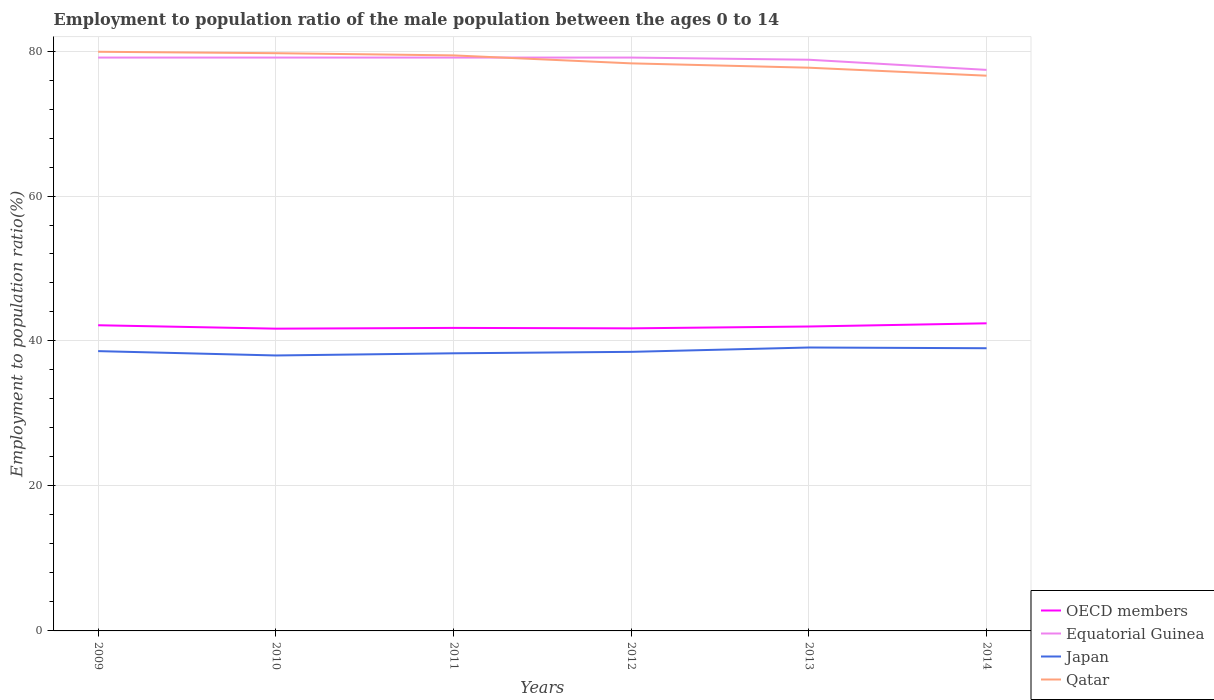Does the line corresponding to Japan intersect with the line corresponding to Equatorial Guinea?
Ensure brevity in your answer.  No. Across all years, what is the maximum employment to population ratio in OECD members?
Offer a very short reply. 41.7. In which year was the employment to population ratio in Equatorial Guinea maximum?
Your answer should be very brief. 2014. What is the total employment to population ratio in Equatorial Guinea in the graph?
Your response must be concise. 1.7. What is the difference between the highest and the second highest employment to population ratio in OECD members?
Provide a short and direct response. 0.74. Is the employment to population ratio in OECD members strictly greater than the employment to population ratio in Japan over the years?
Your answer should be very brief. No. How many lines are there?
Your response must be concise. 4. Are the values on the major ticks of Y-axis written in scientific E-notation?
Make the answer very short. No. Does the graph contain any zero values?
Your response must be concise. No. How are the legend labels stacked?
Your response must be concise. Vertical. What is the title of the graph?
Ensure brevity in your answer.  Employment to population ratio of the male population between the ages 0 to 14. Does "Turkey" appear as one of the legend labels in the graph?
Keep it short and to the point. No. What is the label or title of the X-axis?
Give a very brief answer. Years. What is the label or title of the Y-axis?
Provide a short and direct response. Employment to population ratio(%). What is the Employment to population ratio(%) in OECD members in 2009?
Offer a terse response. 42.17. What is the Employment to population ratio(%) in Equatorial Guinea in 2009?
Give a very brief answer. 79.1. What is the Employment to population ratio(%) of Japan in 2009?
Your answer should be very brief. 38.6. What is the Employment to population ratio(%) in Qatar in 2009?
Your answer should be compact. 79.9. What is the Employment to population ratio(%) of OECD members in 2010?
Give a very brief answer. 41.7. What is the Employment to population ratio(%) of Equatorial Guinea in 2010?
Your response must be concise. 79.1. What is the Employment to population ratio(%) in Japan in 2010?
Ensure brevity in your answer.  38. What is the Employment to population ratio(%) in Qatar in 2010?
Your response must be concise. 79.7. What is the Employment to population ratio(%) in OECD members in 2011?
Make the answer very short. 41.8. What is the Employment to population ratio(%) in Equatorial Guinea in 2011?
Your answer should be very brief. 79.1. What is the Employment to population ratio(%) of Japan in 2011?
Your answer should be very brief. 38.3. What is the Employment to population ratio(%) of Qatar in 2011?
Your answer should be compact. 79.4. What is the Employment to population ratio(%) of OECD members in 2012?
Keep it short and to the point. 41.74. What is the Employment to population ratio(%) of Equatorial Guinea in 2012?
Ensure brevity in your answer.  79.1. What is the Employment to population ratio(%) in Japan in 2012?
Keep it short and to the point. 38.5. What is the Employment to population ratio(%) in Qatar in 2012?
Make the answer very short. 78.3. What is the Employment to population ratio(%) in OECD members in 2013?
Your answer should be compact. 42. What is the Employment to population ratio(%) of Equatorial Guinea in 2013?
Provide a short and direct response. 78.8. What is the Employment to population ratio(%) of Japan in 2013?
Provide a short and direct response. 39.1. What is the Employment to population ratio(%) of Qatar in 2013?
Give a very brief answer. 77.7. What is the Employment to population ratio(%) in OECD members in 2014?
Give a very brief answer. 42.44. What is the Employment to population ratio(%) of Equatorial Guinea in 2014?
Offer a terse response. 77.4. What is the Employment to population ratio(%) in Japan in 2014?
Offer a terse response. 39. What is the Employment to population ratio(%) of Qatar in 2014?
Provide a succinct answer. 76.6. Across all years, what is the maximum Employment to population ratio(%) in OECD members?
Your response must be concise. 42.44. Across all years, what is the maximum Employment to population ratio(%) of Equatorial Guinea?
Provide a short and direct response. 79.1. Across all years, what is the maximum Employment to population ratio(%) in Japan?
Your response must be concise. 39.1. Across all years, what is the maximum Employment to population ratio(%) in Qatar?
Provide a succinct answer. 79.9. Across all years, what is the minimum Employment to population ratio(%) in OECD members?
Make the answer very short. 41.7. Across all years, what is the minimum Employment to population ratio(%) in Equatorial Guinea?
Provide a short and direct response. 77.4. Across all years, what is the minimum Employment to population ratio(%) of Japan?
Keep it short and to the point. 38. Across all years, what is the minimum Employment to population ratio(%) of Qatar?
Make the answer very short. 76.6. What is the total Employment to population ratio(%) in OECD members in the graph?
Offer a terse response. 251.85. What is the total Employment to population ratio(%) of Equatorial Guinea in the graph?
Your answer should be compact. 472.6. What is the total Employment to population ratio(%) in Japan in the graph?
Offer a very short reply. 231.5. What is the total Employment to population ratio(%) in Qatar in the graph?
Keep it short and to the point. 471.6. What is the difference between the Employment to population ratio(%) of OECD members in 2009 and that in 2010?
Provide a short and direct response. 0.47. What is the difference between the Employment to population ratio(%) in Japan in 2009 and that in 2010?
Provide a short and direct response. 0.6. What is the difference between the Employment to population ratio(%) in Qatar in 2009 and that in 2010?
Your answer should be very brief. 0.2. What is the difference between the Employment to population ratio(%) in OECD members in 2009 and that in 2011?
Ensure brevity in your answer.  0.37. What is the difference between the Employment to population ratio(%) in Equatorial Guinea in 2009 and that in 2011?
Give a very brief answer. 0. What is the difference between the Employment to population ratio(%) of Japan in 2009 and that in 2011?
Your answer should be compact. 0.3. What is the difference between the Employment to population ratio(%) in Qatar in 2009 and that in 2011?
Give a very brief answer. 0.5. What is the difference between the Employment to population ratio(%) in OECD members in 2009 and that in 2012?
Your answer should be very brief. 0.43. What is the difference between the Employment to population ratio(%) in Equatorial Guinea in 2009 and that in 2012?
Make the answer very short. 0. What is the difference between the Employment to population ratio(%) of OECD members in 2009 and that in 2013?
Provide a succinct answer. 0.17. What is the difference between the Employment to population ratio(%) of Equatorial Guinea in 2009 and that in 2013?
Ensure brevity in your answer.  0.3. What is the difference between the Employment to population ratio(%) of OECD members in 2009 and that in 2014?
Ensure brevity in your answer.  -0.27. What is the difference between the Employment to population ratio(%) in Equatorial Guinea in 2009 and that in 2014?
Your response must be concise. 1.7. What is the difference between the Employment to population ratio(%) of Japan in 2009 and that in 2014?
Ensure brevity in your answer.  -0.4. What is the difference between the Employment to population ratio(%) of OECD members in 2010 and that in 2011?
Your response must be concise. -0.1. What is the difference between the Employment to population ratio(%) of Japan in 2010 and that in 2011?
Keep it short and to the point. -0.3. What is the difference between the Employment to population ratio(%) in Qatar in 2010 and that in 2011?
Provide a succinct answer. 0.3. What is the difference between the Employment to population ratio(%) in OECD members in 2010 and that in 2012?
Your answer should be very brief. -0.04. What is the difference between the Employment to population ratio(%) in Equatorial Guinea in 2010 and that in 2012?
Offer a terse response. 0. What is the difference between the Employment to population ratio(%) of OECD members in 2010 and that in 2013?
Your answer should be very brief. -0.3. What is the difference between the Employment to population ratio(%) of Equatorial Guinea in 2010 and that in 2013?
Your answer should be compact. 0.3. What is the difference between the Employment to population ratio(%) of Qatar in 2010 and that in 2013?
Ensure brevity in your answer.  2. What is the difference between the Employment to population ratio(%) of OECD members in 2010 and that in 2014?
Your response must be concise. -0.74. What is the difference between the Employment to population ratio(%) in Qatar in 2010 and that in 2014?
Give a very brief answer. 3.1. What is the difference between the Employment to population ratio(%) of OECD members in 2011 and that in 2012?
Ensure brevity in your answer.  0.06. What is the difference between the Employment to population ratio(%) of Equatorial Guinea in 2011 and that in 2012?
Keep it short and to the point. 0. What is the difference between the Employment to population ratio(%) of Japan in 2011 and that in 2012?
Offer a terse response. -0.2. What is the difference between the Employment to population ratio(%) in Qatar in 2011 and that in 2012?
Give a very brief answer. 1.1. What is the difference between the Employment to population ratio(%) in OECD members in 2011 and that in 2013?
Your answer should be compact. -0.19. What is the difference between the Employment to population ratio(%) in Equatorial Guinea in 2011 and that in 2013?
Offer a very short reply. 0.3. What is the difference between the Employment to population ratio(%) in Japan in 2011 and that in 2013?
Ensure brevity in your answer.  -0.8. What is the difference between the Employment to population ratio(%) of Qatar in 2011 and that in 2013?
Provide a succinct answer. 1.7. What is the difference between the Employment to population ratio(%) in OECD members in 2011 and that in 2014?
Your response must be concise. -0.63. What is the difference between the Employment to population ratio(%) of Equatorial Guinea in 2011 and that in 2014?
Give a very brief answer. 1.7. What is the difference between the Employment to population ratio(%) in Japan in 2011 and that in 2014?
Provide a short and direct response. -0.7. What is the difference between the Employment to population ratio(%) in OECD members in 2012 and that in 2013?
Keep it short and to the point. -0.25. What is the difference between the Employment to population ratio(%) of Equatorial Guinea in 2012 and that in 2013?
Offer a terse response. 0.3. What is the difference between the Employment to population ratio(%) of Qatar in 2012 and that in 2013?
Give a very brief answer. 0.6. What is the difference between the Employment to population ratio(%) of OECD members in 2012 and that in 2014?
Make the answer very short. -0.69. What is the difference between the Employment to population ratio(%) in Equatorial Guinea in 2012 and that in 2014?
Your response must be concise. 1.7. What is the difference between the Employment to population ratio(%) in Qatar in 2012 and that in 2014?
Your answer should be very brief. 1.7. What is the difference between the Employment to population ratio(%) of OECD members in 2013 and that in 2014?
Your answer should be very brief. -0.44. What is the difference between the Employment to population ratio(%) in OECD members in 2009 and the Employment to population ratio(%) in Equatorial Guinea in 2010?
Offer a terse response. -36.93. What is the difference between the Employment to population ratio(%) in OECD members in 2009 and the Employment to population ratio(%) in Japan in 2010?
Make the answer very short. 4.17. What is the difference between the Employment to population ratio(%) of OECD members in 2009 and the Employment to population ratio(%) of Qatar in 2010?
Offer a terse response. -37.53. What is the difference between the Employment to population ratio(%) of Equatorial Guinea in 2009 and the Employment to population ratio(%) of Japan in 2010?
Your response must be concise. 41.1. What is the difference between the Employment to population ratio(%) in Equatorial Guinea in 2009 and the Employment to population ratio(%) in Qatar in 2010?
Ensure brevity in your answer.  -0.6. What is the difference between the Employment to population ratio(%) in Japan in 2009 and the Employment to population ratio(%) in Qatar in 2010?
Offer a terse response. -41.1. What is the difference between the Employment to population ratio(%) of OECD members in 2009 and the Employment to population ratio(%) of Equatorial Guinea in 2011?
Offer a very short reply. -36.93. What is the difference between the Employment to population ratio(%) in OECD members in 2009 and the Employment to population ratio(%) in Japan in 2011?
Your answer should be compact. 3.87. What is the difference between the Employment to population ratio(%) of OECD members in 2009 and the Employment to population ratio(%) of Qatar in 2011?
Keep it short and to the point. -37.23. What is the difference between the Employment to population ratio(%) in Equatorial Guinea in 2009 and the Employment to population ratio(%) in Japan in 2011?
Keep it short and to the point. 40.8. What is the difference between the Employment to population ratio(%) in Japan in 2009 and the Employment to population ratio(%) in Qatar in 2011?
Keep it short and to the point. -40.8. What is the difference between the Employment to population ratio(%) in OECD members in 2009 and the Employment to population ratio(%) in Equatorial Guinea in 2012?
Offer a terse response. -36.93. What is the difference between the Employment to population ratio(%) in OECD members in 2009 and the Employment to population ratio(%) in Japan in 2012?
Keep it short and to the point. 3.67. What is the difference between the Employment to population ratio(%) of OECD members in 2009 and the Employment to population ratio(%) of Qatar in 2012?
Your answer should be compact. -36.13. What is the difference between the Employment to population ratio(%) in Equatorial Guinea in 2009 and the Employment to population ratio(%) in Japan in 2012?
Offer a terse response. 40.6. What is the difference between the Employment to population ratio(%) in Japan in 2009 and the Employment to population ratio(%) in Qatar in 2012?
Offer a very short reply. -39.7. What is the difference between the Employment to population ratio(%) in OECD members in 2009 and the Employment to population ratio(%) in Equatorial Guinea in 2013?
Your response must be concise. -36.63. What is the difference between the Employment to population ratio(%) of OECD members in 2009 and the Employment to population ratio(%) of Japan in 2013?
Ensure brevity in your answer.  3.07. What is the difference between the Employment to population ratio(%) of OECD members in 2009 and the Employment to population ratio(%) of Qatar in 2013?
Keep it short and to the point. -35.53. What is the difference between the Employment to population ratio(%) of Equatorial Guinea in 2009 and the Employment to population ratio(%) of Qatar in 2013?
Keep it short and to the point. 1.4. What is the difference between the Employment to population ratio(%) in Japan in 2009 and the Employment to population ratio(%) in Qatar in 2013?
Offer a terse response. -39.1. What is the difference between the Employment to population ratio(%) in OECD members in 2009 and the Employment to population ratio(%) in Equatorial Guinea in 2014?
Your answer should be very brief. -35.23. What is the difference between the Employment to population ratio(%) of OECD members in 2009 and the Employment to population ratio(%) of Japan in 2014?
Offer a very short reply. 3.17. What is the difference between the Employment to population ratio(%) of OECD members in 2009 and the Employment to population ratio(%) of Qatar in 2014?
Provide a short and direct response. -34.43. What is the difference between the Employment to population ratio(%) in Equatorial Guinea in 2009 and the Employment to population ratio(%) in Japan in 2014?
Your answer should be compact. 40.1. What is the difference between the Employment to population ratio(%) in Equatorial Guinea in 2009 and the Employment to population ratio(%) in Qatar in 2014?
Give a very brief answer. 2.5. What is the difference between the Employment to population ratio(%) in Japan in 2009 and the Employment to population ratio(%) in Qatar in 2014?
Offer a terse response. -38. What is the difference between the Employment to population ratio(%) in OECD members in 2010 and the Employment to population ratio(%) in Equatorial Guinea in 2011?
Your answer should be compact. -37.4. What is the difference between the Employment to population ratio(%) of OECD members in 2010 and the Employment to population ratio(%) of Japan in 2011?
Ensure brevity in your answer.  3.4. What is the difference between the Employment to population ratio(%) in OECD members in 2010 and the Employment to population ratio(%) in Qatar in 2011?
Keep it short and to the point. -37.7. What is the difference between the Employment to population ratio(%) of Equatorial Guinea in 2010 and the Employment to population ratio(%) of Japan in 2011?
Keep it short and to the point. 40.8. What is the difference between the Employment to population ratio(%) of Japan in 2010 and the Employment to population ratio(%) of Qatar in 2011?
Provide a short and direct response. -41.4. What is the difference between the Employment to population ratio(%) of OECD members in 2010 and the Employment to population ratio(%) of Equatorial Guinea in 2012?
Give a very brief answer. -37.4. What is the difference between the Employment to population ratio(%) in OECD members in 2010 and the Employment to population ratio(%) in Japan in 2012?
Make the answer very short. 3.2. What is the difference between the Employment to population ratio(%) in OECD members in 2010 and the Employment to population ratio(%) in Qatar in 2012?
Your response must be concise. -36.6. What is the difference between the Employment to population ratio(%) in Equatorial Guinea in 2010 and the Employment to population ratio(%) in Japan in 2012?
Your answer should be compact. 40.6. What is the difference between the Employment to population ratio(%) in Equatorial Guinea in 2010 and the Employment to population ratio(%) in Qatar in 2012?
Your response must be concise. 0.8. What is the difference between the Employment to population ratio(%) of Japan in 2010 and the Employment to population ratio(%) of Qatar in 2012?
Ensure brevity in your answer.  -40.3. What is the difference between the Employment to population ratio(%) of OECD members in 2010 and the Employment to population ratio(%) of Equatorial Guinea in 2013?
Your answer should be very brief. -37.1. What is the difference between the Employment to population ratio(%) of OECD members in 2010 and the Employment to population ratio(%) of Japan in 2013?
Ensure brevity in your answer.  2.6. What is the difference between the Employment to population ratio(%) in OECD members in 2010 and the Employment to population ratio(%) in Qatar in 2013?
Ensure brevity in your answer.  -36. What is the difference between the Employment to population ratio(%) of Japan in 2010 and the Employment to population ratio(%) of Qatar in 2013?
Make the answer very short. -39.7. What is the difference between the Employment to population ratio(%) in OECD members in 2010 and the Employment to population ratio(%) in Equatorial Guinea in 2014?
Your answer should be compact. -35.7. What is the difference between the Employment to population ratio(%) in OECD members in 2010 and the Employment to population ratio(%) in Japan in 2014?
Provide a short and direct response. 2.7. What is the difference between the Employment to population ratio(%) in OECD members in 2010 and the Employment to population ratio(%) in Qatar in 2014?
Your response must be concise. -34.9. What is the difference between the Employment to population ratio(%) of Equatorial Guinea in 2010 and the Employment to population ratio(%) of Japan in 2014?
Make the answer very short. 40.1. What is the difference between the Employment to population ratio(%) of Japan in 2010 and the Employment to population ratio(%) of Qatar in 2014?
Provide a succinct answer. -38.6. What is the difference between the Employment to population ratio(%) of OECD members in 2011 and the Employment to population ratio(%) of Equatorial Guinea in 2012?
Keep it short and to the point. -37.3. What is the difference between the Employment to population ratio(%) of OECD members in 2011 and the Employment to population ratio(%) of Japan in 2012?
Give a very brief answer. 3.3. What is the difference between the Employment to population ratio(%) of OECD members in 2011 and the Employment to population ratio(%) of Qatar in 2012?
Offer a terse response. -36.5. What is the difference between the Employment to population ratio(%) of Equatorial Guinea in 2011 and the Employment to population ratio(%) of Japan in 2012?
Provide a short and direct response. 40.6. What is the difference between the Employment to population ratio(%) of OECD members in 2011 and the Employment to population ratio(%) of Equatorial Guinea in 2013?
Your response must be concise. -37. What is the difference between the Employment to population ratio(%) in OECD members in 2011 and the Employment to population ratio(%) in Japan in 2013?
Provide a short and direct response. 2.7. What is the difference between the Employment to population ratio(%) in OECD members in 2011 and the Employment to population ratio(%) in Qatar in 2013?
Your answer should be compact. -35.9. What is the difference between the Employment to population ratio(%) in Japan in 2011 and the Employment to population ratio(%) in Qatar in 2013?
Provide a succinct answer. -39.4. What is the difference between the Employment to population ratio(%) in OECD members in 2011 and the Employment to population ratio(%) in Equatorial Guinea in 2014?
Offer a very short reply. -35.6. What is the difference between the Employment to population ratio(%) in OECD members in 2011 and the Employment to population ratio(%) in Japan in 2014?
Make the answer very short. 2.8. What is the difference between the Employment to population ratio(%) of OECD members in 2011 and the Employment to population ratio(%) of Qatar in 2014?
Your response must be concise. -34.8. What is the difference between the Employment to population ratio(%) of Equatorial Guinea in 2011 and the Employment to population ratio(%) of Japan in 2014?
Give a very brief answer. 40.1. What is the difference between the Employment to population ratio(%) in Japan in 2011 and the Employment to population ratio(%) in Qatar in 2014?
Offer a very short reply. -38.3. What is the difference between the Employment to population ratio(%) in OECD members in 2012 and the Employment to population ratio(%) in Equatorial Guinea in 2013?
Offer a very short reply. -37.06. What is the difference between the Employment to population ratio(%) in OECD members in 2012 and the Employment to population ratio(%) in Japan in 2013?
Keep it short and to the point. 2.64. What is the difference between the Employment to population ratio(%) of OECD members in 2012 and the Employment to population ratio(%) of Qatar in 2013?
Make the answer very short. -35.96. What is the difference between the Employment to population ratio(%) of Japan in 2012 and the Employment to population ratio(%) of Qatar in 2013?
Make the answer very short. -39.2. What is the difference between the Employment to population ratio(%) of OECD members in 2012 and the Employment to population ratio(%) of Equatorial Guinea in 2014?
Provide a short and direct response. -35.66. What is the difference between the Employment to population ratio(%) in OECD members in 2012 and the Employment to population ratio(%) in Japan in 2014?
Offer a very short reply. 2.74. What is the difference between the Employment to population ratio(%) of OECD members in 2012 and the Employment to population ratio(%) of Qatar in 2014?
Keep it short and to the point. -34.86. What is the difference between the Employment to population ratio(%) of Equatorial Guinea in 2012 and the Employment to population ratio(%) of Japan in 2014?
Make the answer very short. 40.1. What is the difference between the Employment to population ratio(%) in Equatorial Guinea in 2012 and the Employment to population ratio(%) in Qatar in 2014?
Offer a terse response. 2.5. What is the difference between the Employment to population ratio(%) in Japan in 2012 and the Employment to population ratio(%) in Qatar in 2014?
Your answer should be compact. -38.1. What is the difference between the Employment to population ratio(%) of OECD members in 2013 and the Employment to population ratio(%) of Equatorial Guinea in 2014?
Ensure brevity in your answer.  -35.4. What is the difference between the Employment to population ratio(%) in OECD members in 2013 and the Employment to population ratio(%) in Japan in 2014?
Make the answer very short. 3. What is the difference between the Employment to population ratio(%) of OECD members in 2013 and the Employment to population ratio(%) of Qatar in 2014?
Offer a terse response. -34.6. What is the difference between the Employment to population ratio(%) in Equatorial Guinea in 2013 and the Employment to population ratio(%) in Japan in 2014?
Make the answer very short. 39.8. What is the difference between the Employment to population ratio(%) in Equatorial Guinea in 2013 and the Employment to population ratio(%) in Qatar in 2014?
Offer a terse response. 2.2. What is the difference between the Employment to population ratio(%) in Japan in 2013 and the Employment to population ratio(%) in Qatar in 2014?
Offer a very short reply. -37.5. What is the average Employment to population ratio(%) of OECD members per year?
Offer a terse response. 41.98. What is the average Employment to population ratio(%) in Equatorial Guinea per year?
Offer a terse response. 78.77. What is the average Employment to population ratio(%) in Japan per year?
Your answer should be compact. 38.58. What is the average Employment to population ratio(%) of Qatar per year?
Ensure brevity in your answer.  78.6. In the year 2009, what is the difference between the Employment to population ratio(%) in OECD members and Employment to population ratio(%) in Equatorial Guinea?
Your answer should be very brief. -36.93. In the year 2009, what is the difference between the Employment to population ratio(%) in OECD members and Employment to population ratio(%) in Japan?
Offer a very short reply. 3.57. In the year 2009, what is the difference between the Employment to population ratio(%) in OECD members and Employment to population ratio(%) in Qatar?
Provide a succinct answer. -37.73. In the year 2009, what is the difference between the Employment to population ratio(%) in Equatorial Guinea and Employment to population ratio(%) in Japan?
Keep it short and to the point. 40.5. In the year 2009, what is the difference between the Employment to population ratio(%) in Equatorial Guinea and Employment to population ratio(%) in Qatar?
Ensure brevity in your answer.  -0.8. In the year 2009, what is the difference between the Employment to population ratio(%) of Japan and Employment to population ratio(%) of Qatar?
Keep it short and to the point. -41.3. In the year 2010, what is the difference between the Employment to population ratio(%) in OECD members and Employment to population ratio(%) in Equatorial Guinea?
Make the answer very short. -37.4. In the year 2010, what is the difference between the Employment to population ratio(%) of OECD members and Employment to population ratio(%) of Japan?
Keep it short and to the point. 3.7. In the year 2010, what is the difference between the Employment to population ratio(%) in OECD members and Employment to population ratio(%) in Qatar?
Ensure brevity in your answer.  -38. In the year 2010, what is the difference between the Employment to population ratio(%) in Equatorial Guinea and Employment to population ratio(%) in Japan?
Provide a succinct answer. 41.1. In the year 2010, what is the difference between the Employment to population ratio(%) in Japan and Employment to population ratio(%) in Qatar?
Keep it short and to the point. -41.7. In the year 2011, what is the difference between the Employment to population ratio(%) of OECD members and Employment to population ratio(%) of Equatorial Guinea?
Offer a very short reply. -37.3. In the year 2011, what is the difference between the Employment to population ratio(%) in OECD members and Employment to population ratio(%) in Japan?
Make the answer very short. 3.5. In the year 2011, what is the difference between the Employment to population ratio(%) in OECD members and Employment to population ratio(%) in Qatar?
Your answer should be very brief. -37.6. In the year 2011, what is the difference between the Employment to population ratio(%) in Equatorial Guinea and Employment to population ratio(%) in Japan?
Ensure brevity in your answer.  40.8. In the year 2011, what is the difference between the Employment to population ratio(%) of Equatorial Guinea and Employment to population ratio(%) of Qatar?
Provide a short and direct response. -0.3. In the year 2011, what is the difference between the Employment to population ratio(%) of Japan and Employment to population ratio(%) of Qatar?
Keep it short and to the point. -41.1. In the year 2012, what is the difference between the Employment to population ratio(%) of OECD members and Employment to population ratio(%) of Equatorial Guinea?
Provide a short and direct response. -37.36. In the year 2012, what is the difference between the Employment to population ratio(%) in OECD members and Employment to population ratio(%) in Japan?
Your answer should be compact. 3.24. In the year 2012, what is the difference between the Employment to population ratio(%) in OECD members and Employment to population ratio(%) in Qatar?
Your answer should be compact. -36.56. In the year 2012, what is the difference between the Employment to population ratio(%) in Equatorial Guinea and Employment to population ratio(%) in Japan?
Ensure brevity in your answer.  40.6. In the year 2012, what is the difference between the Employment to population ratio(%) in Equatorial Guinea and Employment to population ratio(%) in Qatar?
Keep it short and to the point. 0.8. In the year 2012, what is the difference between the Employment to population ratio(%) of Japan and Employment to population ratio(%) of Qatar?
Offer a terse response. -39.8. In the year 2013, what is the difference between the Employment to population ratio(%) in OECD members and Employment to population ratio(%) in Equatorial Guinea?
Provide a succinct answer. -36.8. In the year 2013, what is the difference between the Employment to population ratio(%) in OECD members and Employment to population ratio(%) in Japan?
Offer a very short reply. 2.9. In the year 2013, what is the difference between the Employment to population ratio(%) in OECD members and Employment to population ratio(%) in Qatar?
Keep it short and to the point. -35.7. In the year 2013, what is the difference between the Employment to population ratio(%) of Equatorial Guinea and Employment to population ratio(%) of Japan?
Your answer should be very brief. 39.7. In the year 2013, what is the difference between the Employment to population ratio(%) of Equatorial Guinea and Employment to population ratio(%) of Qatar?
Your answer should be compact. 1.1. In the year 2013, what is the difference between the Employment to population ratio(%) in Japan and Employment to population ratio(%) in Qatar?
Provide a succinct answer. -38.6. In the year 2014, what is the difference between the Employment to population ratio(%) in OECD members and Employment to population ratio(%) in Equatorial Guinea?
Offer a very short reply. -34.96. In the year 2014, what is the difference between the Employment to population ratio(%) in OECD members and Employment to population ratio(%) in Japan?
Give a very brief answer. 3.44. In the year 2014, what is the difference between the Employment to population ratio(%) in OECD members and Employment to population ratio(%) in Qatar?
Provide a succinct answer. -34.16. In the year 2014, what is the difference between the Employment to population ratio(%) in Equatorial Guinea and Employment to population ratio(%) in Japan?
Give a very brief answer. 38.4. In the year 2014, what is the difference between the Employment to population ratio(%) of Japan and Employment to population ratio(%) of Qatar?
Provide a short and direct response. -37.6. What is the ratio of the Employment to population ratio(%) in OECD members in 2009 to that in 2010?
Provide a succinct answer. 1.01. What is the ratio of the Employment to population ratio(%) in Japan in 2009 to that in 2010?
Provide a short and direct response. 1.02. What is the ratio of the Employment to population ratio(%) in Qatar in 2009 to that in 2010?
Make the answer very short. 1. What is the ratio of the Employment to population ratio(%) of OECD members in 2009 to that in 2011?
Give a very brief answer. 1.01. What is the ratio of the Employment to population ratio(%) in OECD members in 2009 to that in 2012?
Provide a succinct answer. 1.01. What is the ratio of the Employment to population ratio(%) in Qatar in 2009 to that in 2012?
Provide a succinct answer. 1.02. What is the ratio of the Employment to population ratio(%) in Japan in 2009 to that in 2013?
Provide a short and direct response. 0.99. What is the ratio of the Employment to population ratio(%) in Qatar in 2009 to that in 2013?
Offer a very short reply. 1.03. What is the ratio of the Employment to population ratio(%) of OECD members in 2009 to that in 2014?
Ensure brevity in your answer.  0.99. What is the ratio of the Employment to population ratio(%) in Equatorial Guinea in 2009 to that in 2014?
Your response must be concise. 1.02. What is the ratio of the Employment to population ratio(%) of Japan in 2009 to that in 2014?
Ensure brevity in your answer.  0.99. What is the ratio of the Employment to population ratio(%) of Qatar in 2009 to that in 2014?
Your response must be concise. 1.04. What is the ratio of the Employment to population ratio(%) in Equatorial Guinea in 2010 to that in 2011?
Your response must be concise. 1. What is the ratio of the Employment to population ratio(%) in Japan in 2010 to that in 2011?
Keep it short and to the point. 0.99. What is the ratio of the Employment to population ratio(%) in Qatar in 2010 to that in 2011?
Make the answer very short. 1. What is the ratio of the Employment to population ratio(%) in Qatar in 2010 to that in 2012?
Make the answer very short. 1.02. What is the ratio of the Employment to population ratio(%) in Equatorial Guinea in 2010 to that in 2013?
Offer a terse response. 1. What is the ratio of the Employment to population ratio(%) of Japan in 2010 to that in 2013?
Provide a short and direct response. 0.97. What is the ratio of the Employment to population ratio(%) in Qatar in 2010 to that in 2013?
Your response must be concise. 1.03. What is the ratio of the Employment to population ratio(%) in OECD members in 2010 to that in 2014?
Your answer should be compact. 0.98. What is the ratio of the Employment to population ratio(%) in Equatorial Guinea in 2010 to that in 2014?
Make the answer very short. 1.02. What is the ratio of the Employment to population ratio(%) in Japan in 2010 to that in 2014?
Provide a succinct answer. 0.97. What is the ratio of the Employment to population ratio(%) of Qatar in 2010 to that in 2014?
Provide a succinct answer. 1.04. What is the ratio of the Employment to population ratio(%) of Equatorial Guinea in 2011 to that in 2012?
Ensure brevity in your answer.  1. What is the ratio of the Employment to population ratio(%) of Equatorial Guinea in 2011 to that in 2013?
Offer a very short reply. 1. What is the ratio of the Employment to population ratio(%) of Japan in 2011 to that in 2013?
Offer a terse response. 0.98. What is the ratio of the Employment to population ratio(%) of Qatar in 2011 to that in 2013?
Make the answer very short. 1.02. What is the ratio of the Employment to population ratio(%) in OECD members in 2011 to that in 2014?
Make the answer very short. 0.99. What is the ratio of the Employment to population ratio(%) of Japan in 2011 to that in 2014?
Offer a terse response. 0.98. What is the ratio of the Employment to population ratio(%) in Qatar in 2011 to that in 2014?
Give a very brief answer. 1.04. What is the ratio of the Employment to population ratio(%) of OECD members in 2012 to that in 2013?
Provide a short and direct response. 0.99. What is the ratio of the Employment to population ratio(%) of Japan in 2012 to that in 2013?
Offer a very short reply. 0.98. What is the ratio of the Employment to population ratio(%) of Qatar in 2012 to that in 2013?
Provide a short and direct response. 1.01. What is the ratio of the Employment to population ratio(%) of OECD members in 2012 to that in 2014?
Make the answer very short. 0.98. What is the ratio of the Employment to population ratio(%) in Equatorial Guinea in 2012 to that in 2014?
Provide a succinct answer. 1.02. What is the ratio of the Employment to population ratio(%) of Japan in 2012 to that in 2014?
Your response must be concise. 0.99. What is the ratio of the Employment to population ratio(%) in Qatar in 2012 to that in 2014?
Give a very brief answer. 1.02. What is the ratio of the Employment to population ratio(%) in Equatorial Guinea in 2013 to that in 2014?
Your answer should be compact. 1.02. What is the ratio of the Employment to population ratio(%) in Japan in 2013 to that in 2014?
Give a very brief answer. 1. What is the ratio of the Employment to population ratio(%) in Qatar in 2013 to that in 2014?
Offer a very short reply. 1.01. What is the difference between the highest and the second highest Employment to population ratio(%) of OECD members?
Keep it short and to the point. 0.27. What is the difference between the highest and the second highest Employment to population ratio(%) in Japan?
Offer a very short reply. 0.1. What is the difference between the highest and the lowest Employment to population ratio(%) in OECD members?
Give a very brief answer. 0.74. What is the difference between the highest and the lowest Employment to population ratio(%) in Japan?
Provide a short and direct response. 1.1. What is the difference between the highest and the lowest Employment to population ratio(%) in Qatar?
Ensure brevity in your answer.  3.3. 